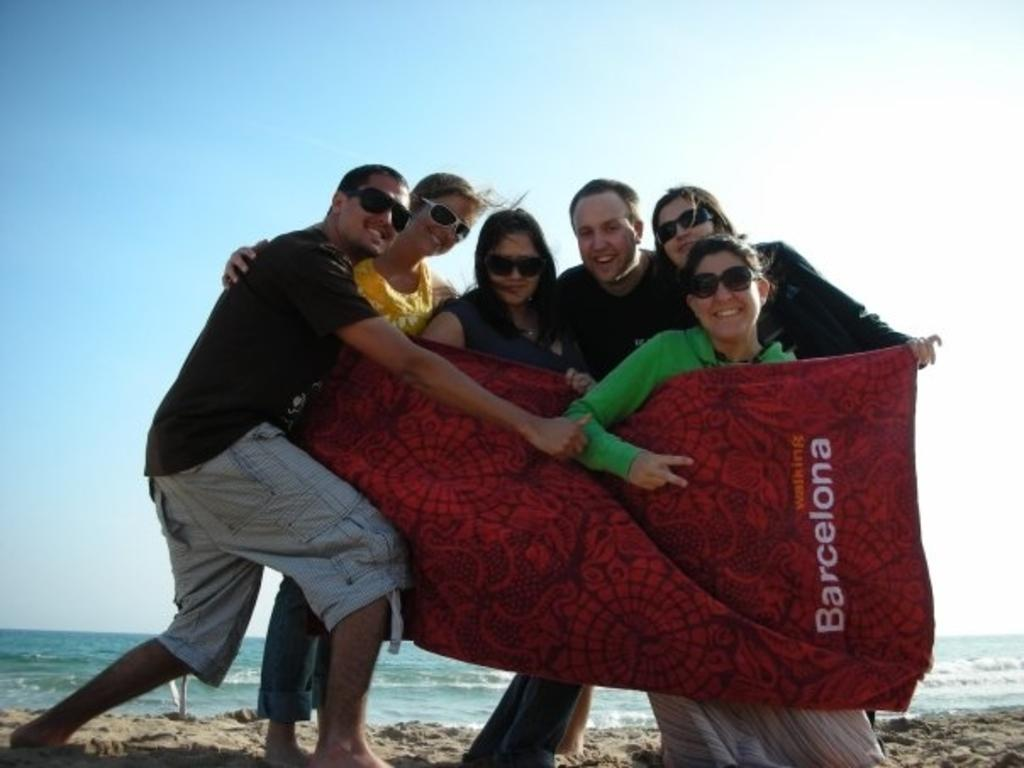What is the main subject of the image? The main subject of the image is a group of people. Can you describe the appearance of some people in the group? Some people in the group are wearing spectacles. What are the people in the image holding? The people are holding a cloth. What can be seen in the background of the image? There is water visible in the background of the image. How many boots are visible in the image? There are no boots present in the image. What type of bikes can be seen in the background of the image? There are no bikes present in the image; only water is visible in the background. 